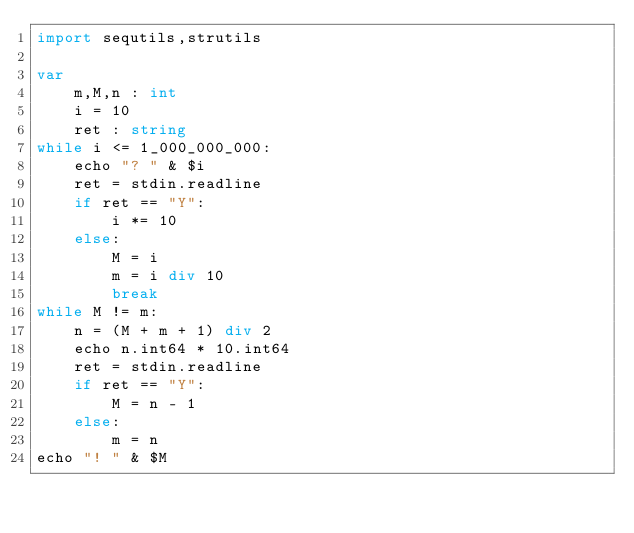Convert code to text. <code><loc_0><loc_0><loc_500><loc_500><_Nim_>import sequtils,strutils

var
    m,M,n : int
    i = 10
    ret : string
while i <= 1_000_000_000:
    echo "? " & $i
    ret = stdin.readline
    if ret == "Y":
        i *= 10
    else:
        M = i
        m = i div 10
        break
while M != m:
    n = (M + m + 1) div 2
    echo n.int64 * 10.int64
    ret = stdin.readline
    if ret == "Y":
        M = n - 1
    else:
        m = n
echo "! " & $M</code> 